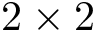<formula> <loc_0><loc_0><loc_500><loc_500>2 \times 2</formula> 